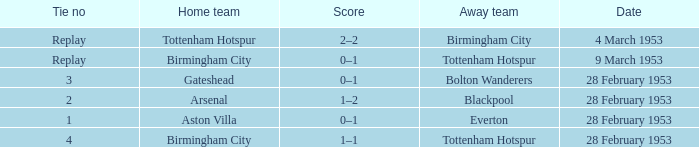Which Tie no has a Score of 0–1, and a Date of 9 march 1953? Replay. 